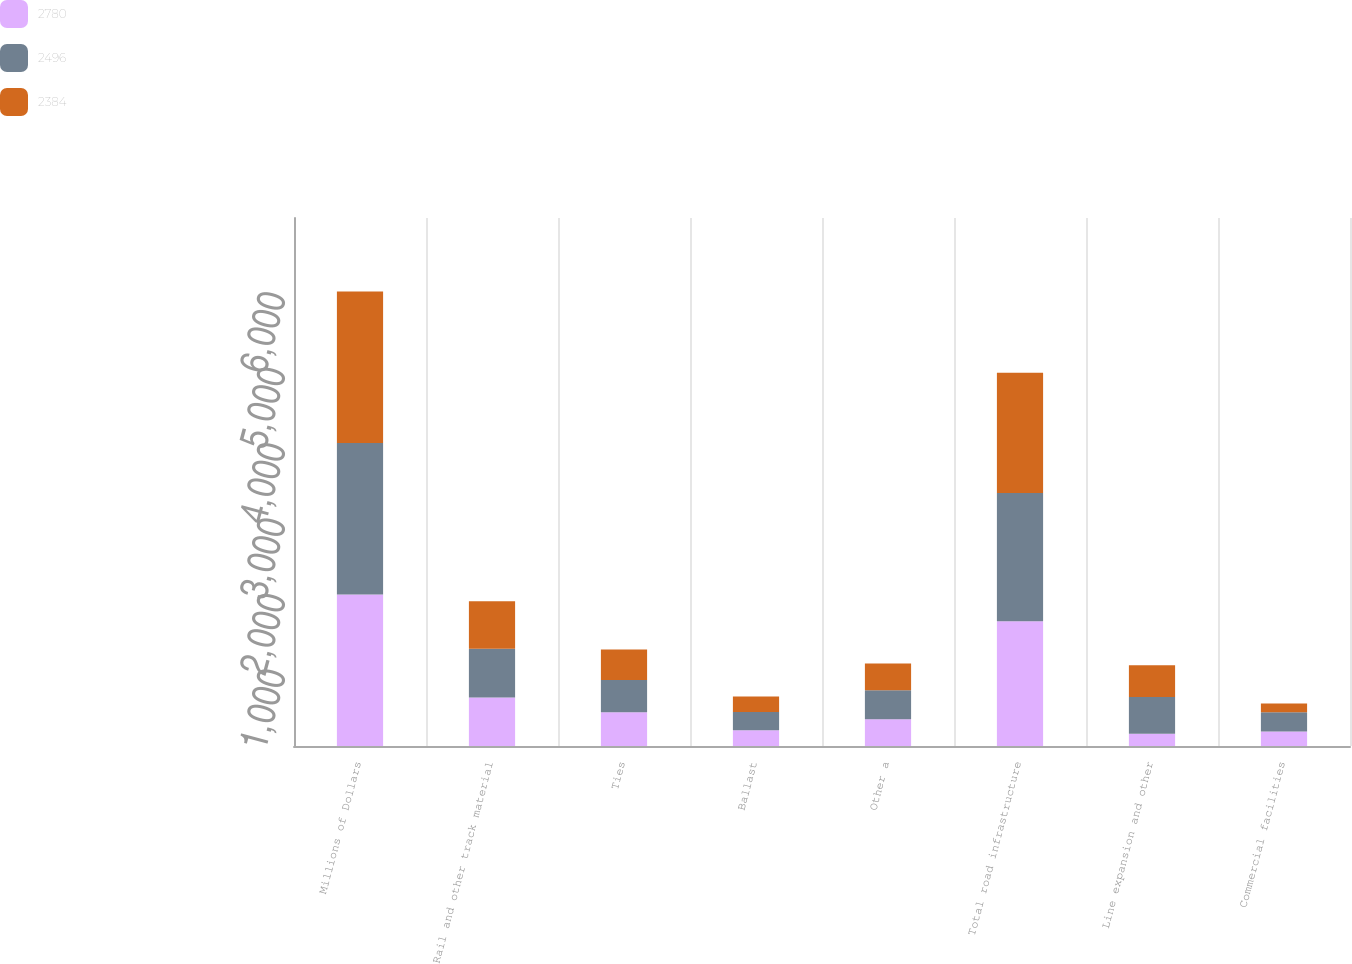Convert chart to OTSL. <chart><loc_0><loc_0><loc_500><loc_500><stacked_bar_chart><ecel><fcel>Millions of Dollars<fcel>Rail and other track material<fcel>Ties<fcel>Ballast<fcel>Other a<fcel>Total road infrastructure<fcel>Line expansion and other<fcel>Commercial facilities<nl><fcel>2780<fcel>2009<fcel>644<fcel>449<fcel>208<fcel>354<fcel>1655<fcel>162<fcel>193<nl><fcel>2496<fcel>2008<fcel>646<fcel>425<fcel>243<fcel>386<fcel>1700<fcel>488<fcel>254<nl><fcel>2384<fcel>2007<fcel>628<fcel>404<fcel>206<fcel>355<fcel>1593<fcel>419<fcel>115<nl></chart> 